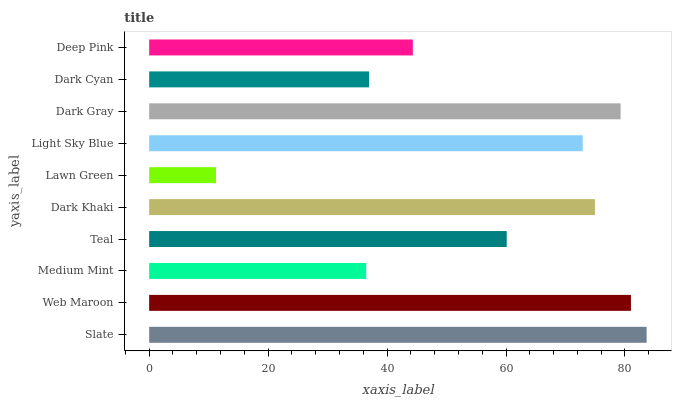Is Lawn Green the minimum?
Answer yes or no. Yes. Is Slate the maximum?
Answer yes or no. Yes. Is Web Maroon the minimum?
Answer yes or no. No. Is Web Maroon the maximum?
Answer yes or no. No. Is Slate greater than Web Maroon?
Answer yes or no. Yes. Is Web Maroon less than Slate?
Answer yes or no. Yes. Is Web Maroon greater than Slate?
Answer yes or no. No. Is Slate less than Web Maroon?
Answer yes or no. No. Is Light Sky Blue the high median?
Answer yes or no. Yes. Is Teal the low median?
Answer yes or no. Yes. Is Dark Gray the high median?
Answer yes or no. No. Is Dark Khaki the low median?
Answer yes or no. No. 